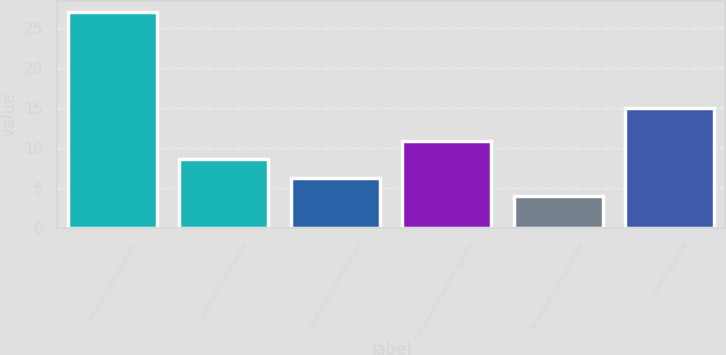<chart> <loc_0><loc_0><loc_500><loc_500><bar_chart><fcel>Personal Communications<fcel>Global Telecom Solutions<fcel>Commercial Government and<fcel>Integrated Electronic Systems<fcel>Broadband Communications<fcel>General Corporate<nl><fcel>27<fcel>8.6<fcel>6.3<fcel>10.9<fcel>4<fcel>15<nl></chart> 